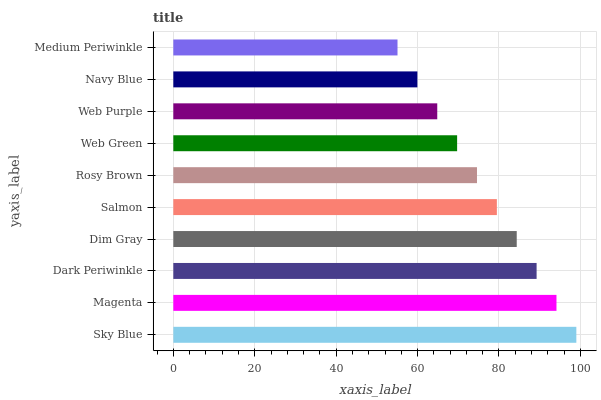Is Medium Periwinkle the minimum?
Answer yes or no. Yes. Is Sky Blue the maximum?
Answer yes or no. Yes. Is Magenta the minimum?
Answer yes or no. No. Is Magenta the maximum?
Answer yes or no. No. Is Sky Blue greater than Magenta?
Answer yes or no. Yes. Is Magenta less than Sky Blue?
Answer yes or no. Yes. Is Magenta greater than Sky Blue?
Answer yes or no. No. Is Sky Blue less than Magenta?
Answer yes or no. No. Is Salmon the high median?
Answer yes or no. Yes. Is Rosy Brown the low median?
Answer yes or no. Yes. Is Rosy Brown the high median?
Answer yes or no. No. Is Dark Periwinkle the low median?
Answer yes or no. No. 